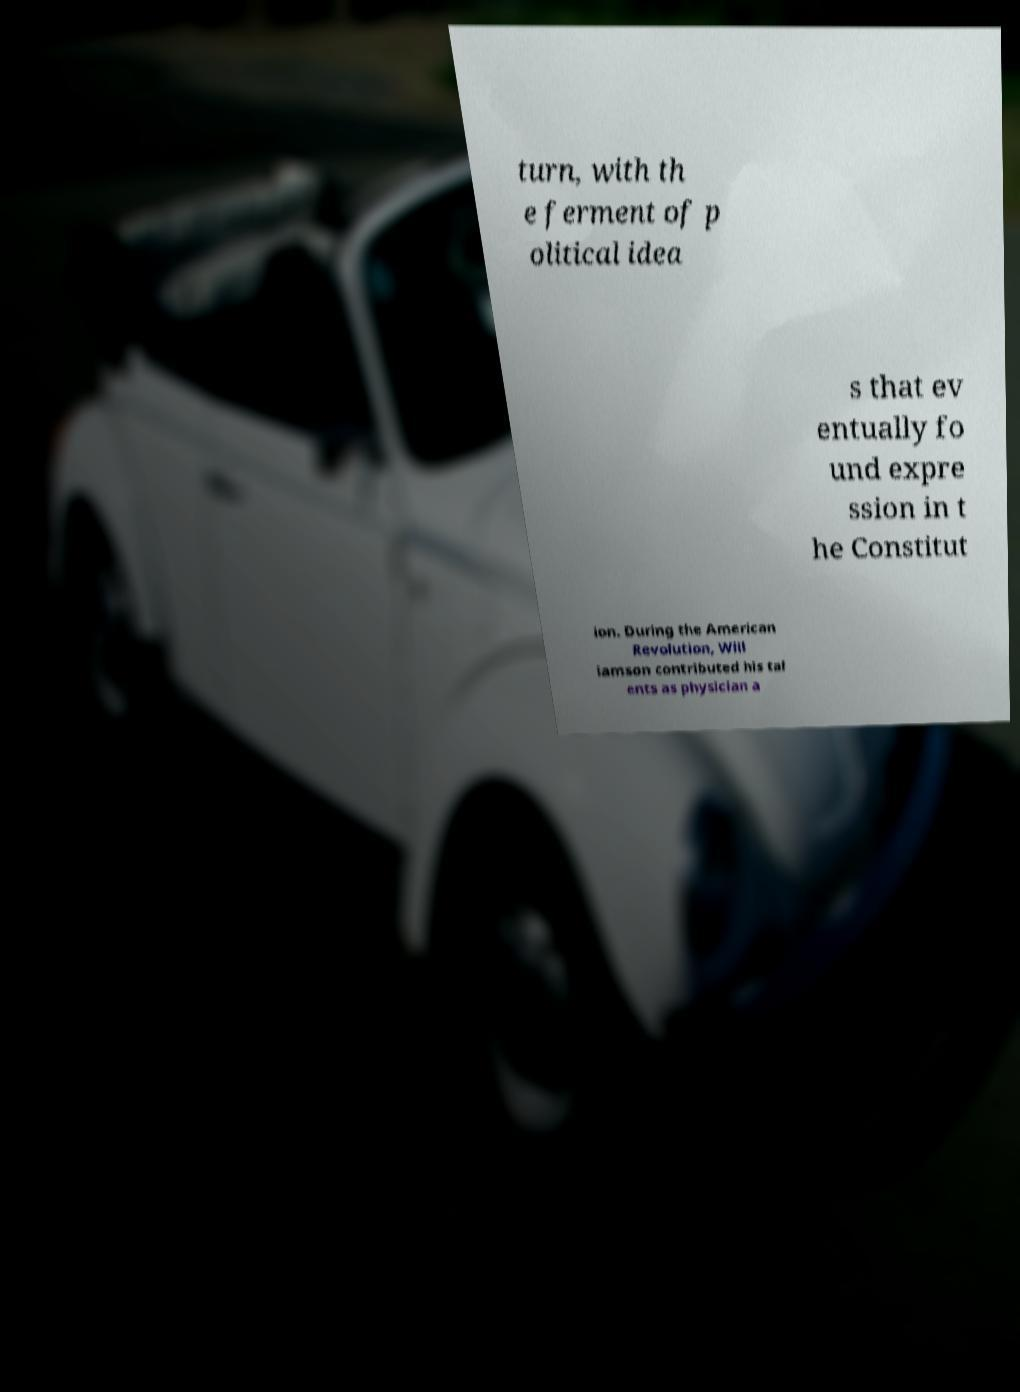Could you assist in decoding the text presented in this image and type it out clearly? turn, with th e ferment of p olitical idea s that ev entually fo und expre ssion in t he Constitut ion. During the American Revolution, Will iamson contributed his tal ents as physician a 